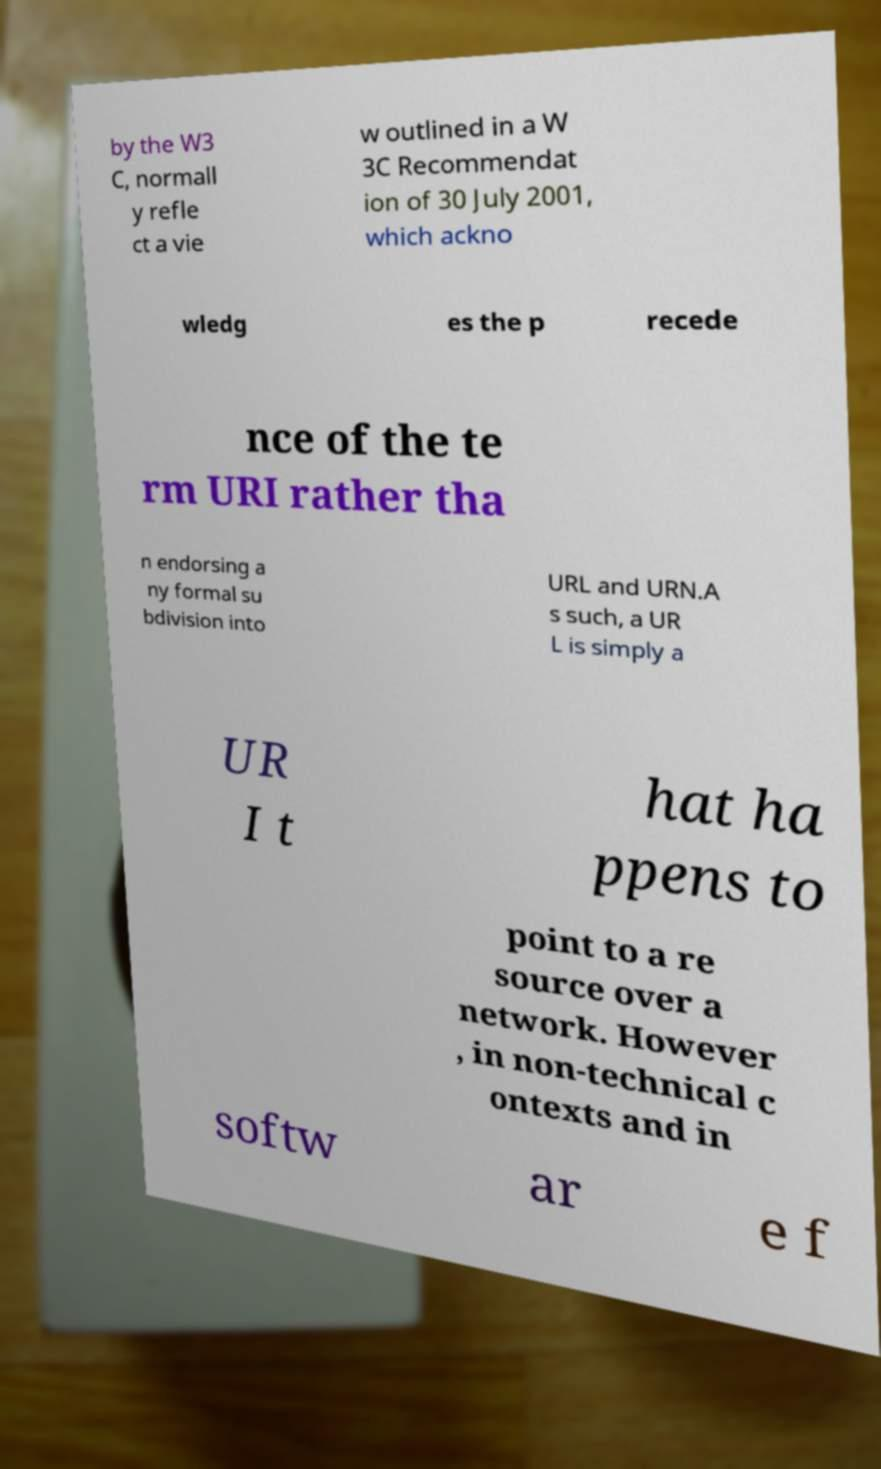Can you read and provide the text displayed in the image?This photo seems to have some interesting text. Can you extract and type it out for me? by the W3 C, normall y refle ct a vie w outlined in a W 3C Recommendat ion of 30 July 2001, which ackno wledg es the p recede nce of the te rm URI rather tha n endorsing a ny formal su bdivision into URL and URN.A s such, a UR L is simply a UR I t hat ha ppens to point to a re source over a network. However , in non-technical c ontexts and in softw ar e f 